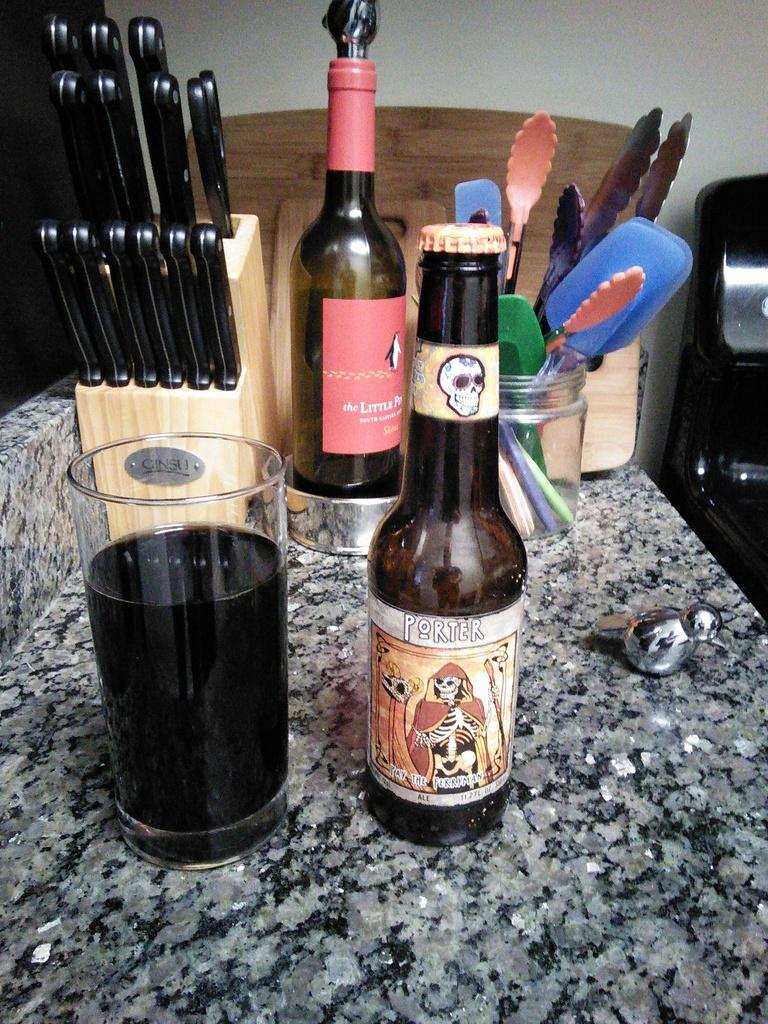<image>
Give a short and clear explanation of the subsequent image. the word Porter is on a beer bottle 